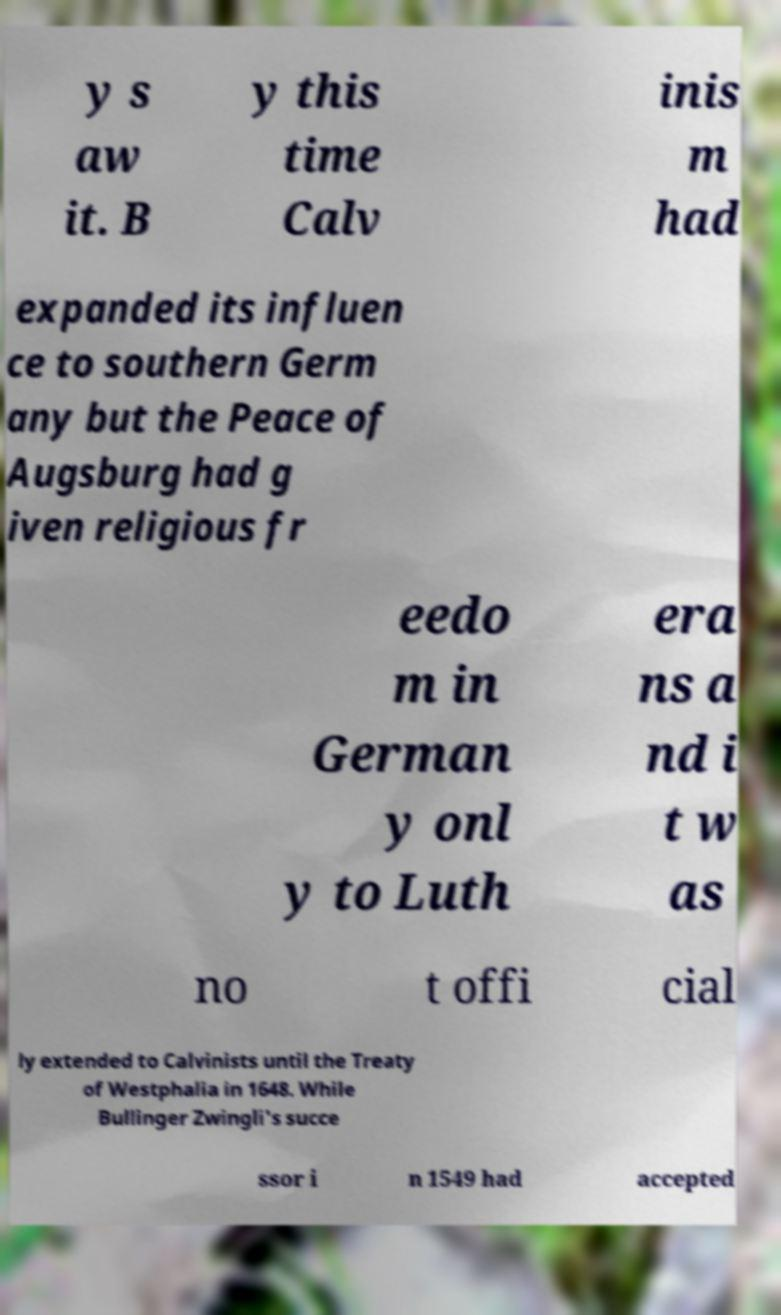Please identify and transcribe the text found in this image. y s aw it. B y this time Calv inis m had expanded its influen ce to southern Germ any but the Peace of Augsburg had g iven religious fr eedo m in German y onl y to Luth era ns a nd i t w as no t offi cial ly extended to Calvinists until the Treaty of Westphalia in 1648. While Bullinger Zwingli's succe ssor i n 1549 had accepted 